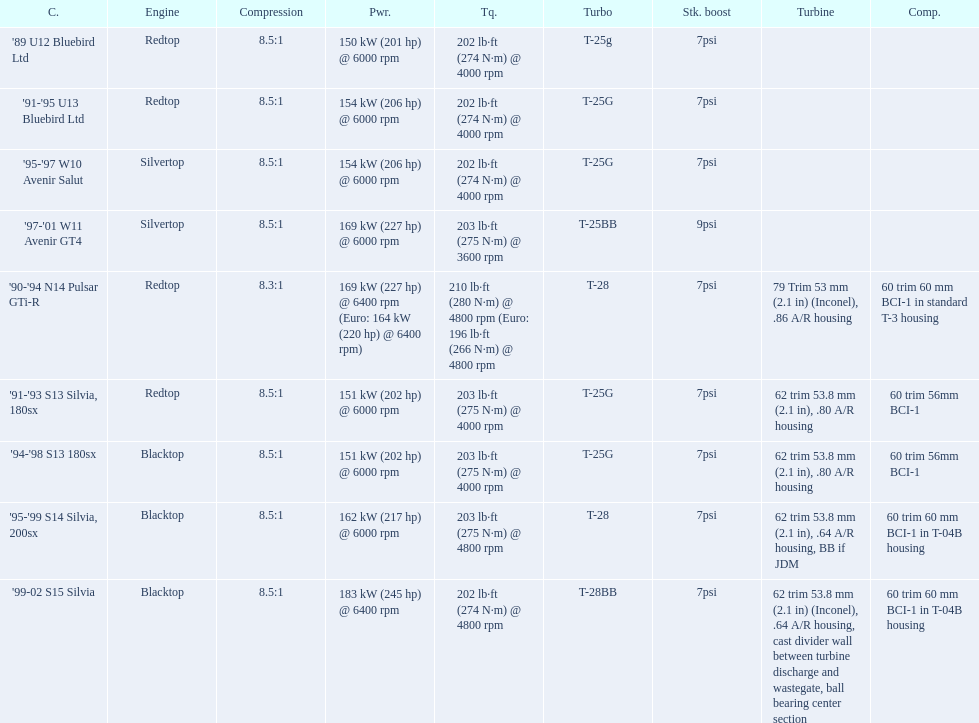Which cars list turbine details? '90-'94 N14 Pulsar GTi-R, '91-'93 S13 Silvia, 180sx, '94-'98 S13 180sx, '95-'99 S14 Silvia, 200sx, '99-02 S15 Silvia. Which of these hit their peak hp at the highest rpm? '90-'94 N14 Pulsar GTi-R, '99-02 S15 Silvia. Of those what is the compression of the only engine that isn't blacktop?? 8.3:1. 